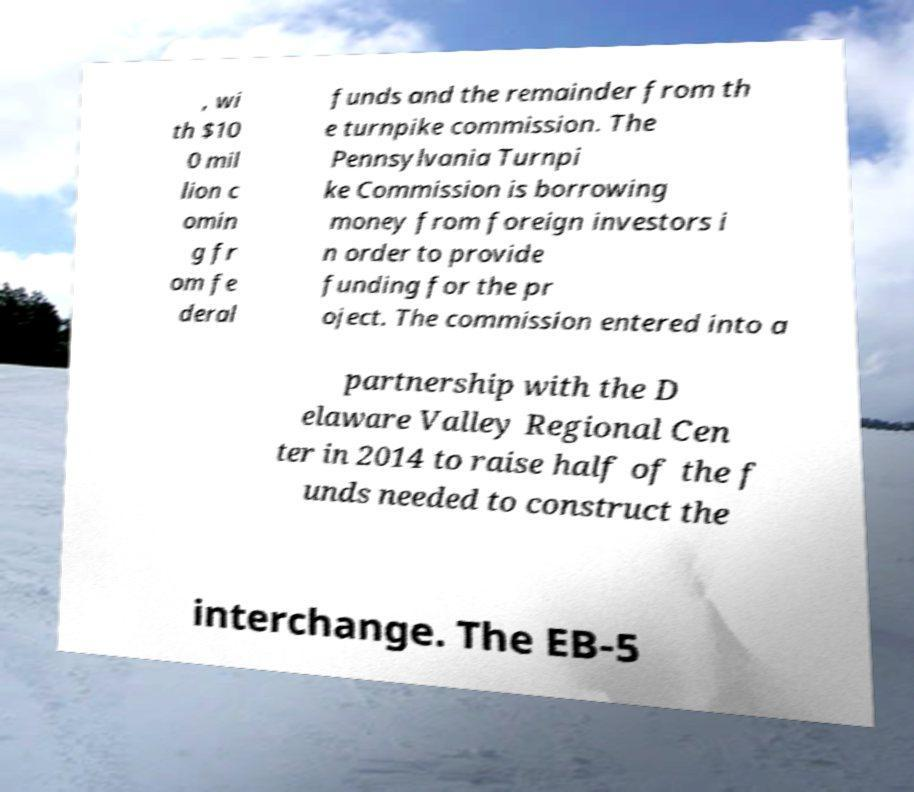Please read and relay the text visible in this image. What does it say? , wi th $10 0 mil lion c omin g fr om fe deral funds and the remainder from th e turnpike commission. The Pennsylvania Turnpi ke Commission is borrowing money from foreign investors i n order to provide funding for the pr oject. The commission entered into a partnership with the D elaware Valley Regional Cen ter in 2014 to raise half of the f unds needed to construct the interchange. The EB-5 